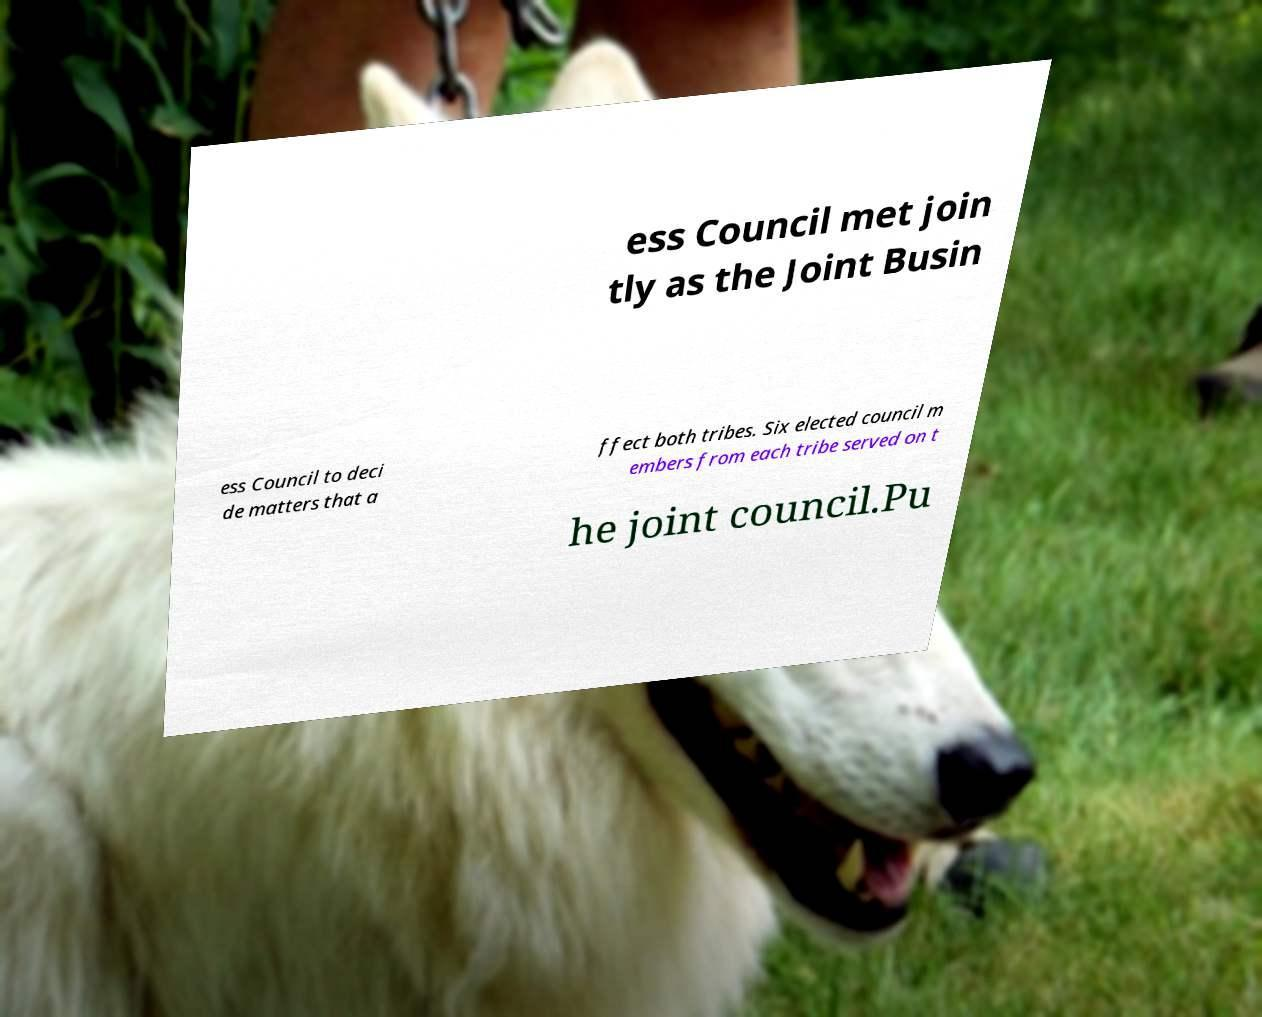Can you accurately transcribe the text from the provided image for me? ess Council met join tly as the Joint Busin ess Council to deci de matters that a ffect both tribes. Six elected council m embers from each tribe served on t he joint council.Pu 